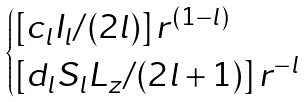Convert formula to latex. <formula><loc_0><loc_0><loc_500><loc_500>\begin{cases} [ c _ { l } I _ { l } / ( 2 l ) ] { \, } r ^ { ( 1 - l ) } \\ [ d _ { l } S _ { l } L _ { z } / ( 2 l + 1 ) ] { \, } r ^ { - l } \end{cases}</formula> 